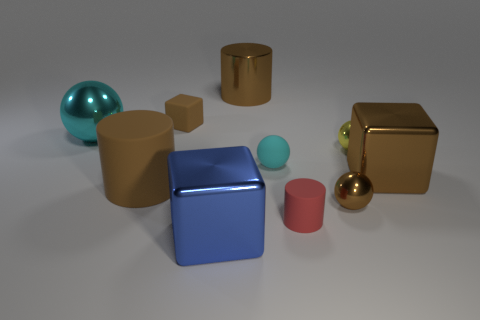Are there any matte spheres that have the same color as the big shiny cylinder?
Your response must be concise. No. What size is the object that is the same color as the big ball?
Provide a succinct answer. Small. There is a big shiny object that is left of the large blue metal object that is in front of the red rubber cylinder; what shape is it?
Your answer should be very brief. Sphere. There is a tiny brown matte thing; does it have the same shape as the large metal object that is on the left side of the tiny brown block?
Make the answer very short. No. What color is the rubber cylinder that is the same size as the yellow object?
Provide a short and direct response. Red. Are there fewer blocks that are to the left of the blue shiny block than cyan rubber objects in front of the red cylinder?
Offer a terse response. No. The small brown thing that is in front of the large metallic cube behind the small brown thing that is to the right of the brown rubber cube is what shape?
Provide a succinct answer. Sphere. There is a big shiny object that is to the left of the large rubber cylinder; does it have the same color as the big cylinder that is in front of the big ball?
Offer a very short reply. No. What is the shape of the metal thing that is the same color as the matte ball?
Your answer should be compact. Sphere. What number of metallic objects are either large balls or large brown cylinders?
Ensure brevity in your answer.  2. 